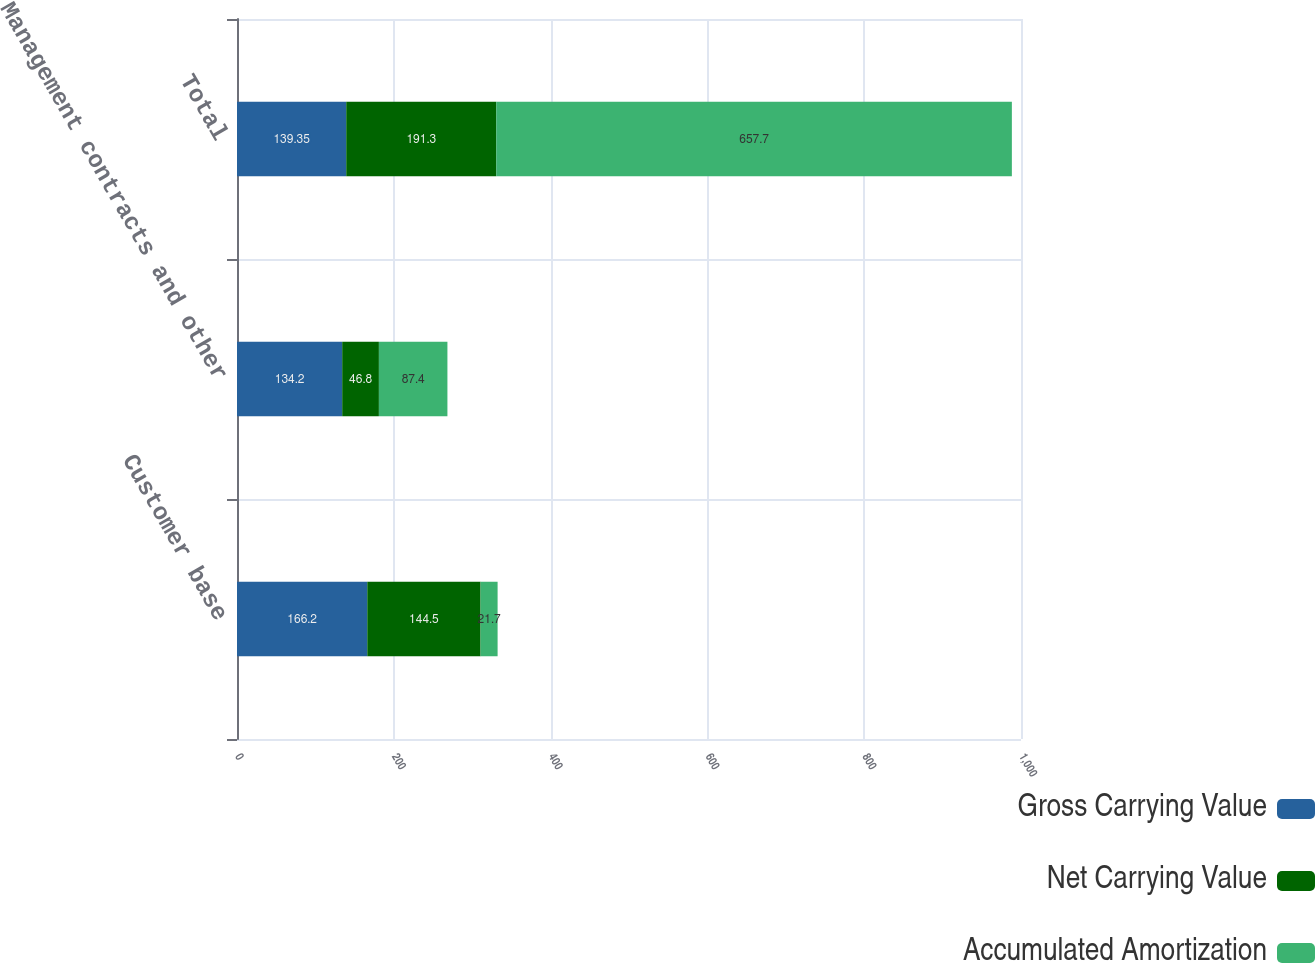<chart> <loc_0><loc_0><loc_500><loc_500><stacked_bar_chart><ecel><fcel>Customer base<fcel>Management contracts and other<fcel>Total<nl><fcel>Gross Carrying Value<fcel>166.2<fcel>134.2<fcel>139.35<nl><fcel>Net Carrying Value<fcel>144.5<fcel>46.8<fcel>191.3<nl><fcel>Accumulated Amortization<fcel>21.7<fcel>87.4<fcel>657.7<nl></chart> 